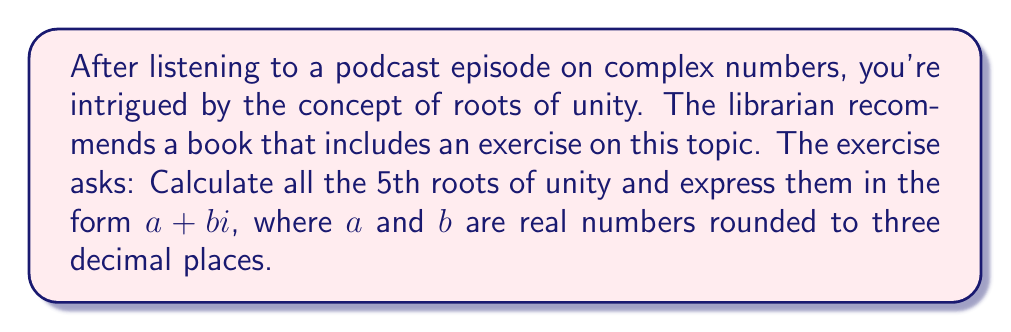Teach me how to tackle this problem. Let's approach this step-by-step:

1) The nth roots of unity are given by the formula:

   $$z_k = e^{2\pi i k/n} = \cos\left(\frac{2\pi k}{n}\right) + i\sin\left(\frac{2\pi k}{n}\right)$$

   where $k = 0, 1, 2, ..., n-1$

2) In this case, $n = 5$, so we need to calculate:

   $$z_k = \cos\left(\frac{2\pi k}{5}\right) + i\sin\left(\frac{2\pi k}{5}\right)$$

   for $k = 0, 1, 2, 3, 4$

3) Let's calculate each root:

   For $k = 0$:
   $$z_0 = \cos(0) + i\sin(0) = 1 + 0i = 1$$

   For $k = 1$:
   $$z_1 = \cos\left(\frac{2\pi}{5}\right) + i\sin\left(\frac{2\pi}{5}\right) \approx 0.309 + 0.951i$$

   For $k = 2$:
   $$z_2 = \cos\left(\frac{4\pi}{5}\right) + i\sin\left(\frac{4\pi}{5}\right) \approx -0.809 + 0.588i$$

   For $k = 3$:
   $$z_3 = \cos\left(\frac{6\pi}{5}\right) + i\sin\left(\frac{6\pi}{5}\right) \approx -0.809 - 0.588i$$

   For $k = 4$:
   $$z_4 = \cos\left(\frac{8\pi}{5}\right) + i\sin\left(\frac{8\pi}{5}\right) \approx 0.309 - 0.951i$$

4) All results are rounded to three decimal places as requested.
Answer: $1$, $0.309 + 0.951i$, $-0.809 + 0.588i$, $-0.809 - 0.588i$, $0.309 - 0.951i$ 